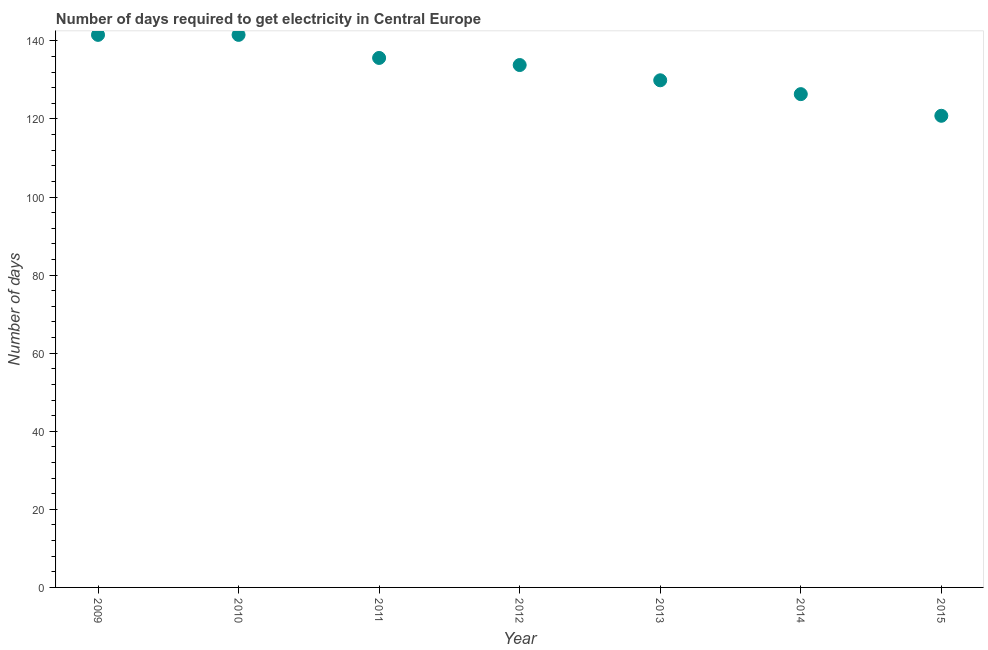What is the time to get electricity in 2010?
Your answer should be compact. 141.55. Across all years, what is the maximum time to get electricity?
Offer a terse response. 141.55. Across all years, what is the minimum time to get electricity?
Make the answer very short. 120.82. In which year was the time to get electricity minimum?
Your response must be concise. 2015. What is the sum of the time to get electricity?
Provide a short and direct response. 929.64. What is the average time to get electricity per year?
Make the answer very short. 132.81. What is the median time to get electricity?
Offer a terse response. 133.82. In how many years, is the time to get electricity greater than 72 ?
Your answer should be very brief. 7. What is the ratio of the time to get electricity in 2011 to that in 2014?
Make the answer very short. 1.07. Is the time to get electricity in 2013 less than that in 2014?
Your response must be concise. No. Is the difference between the time to get electricity in 2011 and 2012 greater than the difference between any two years?
Keep it short and to the point. No. What is the difference between the highest and the second highest time to get electricity?
Your answer should be very brief. 0. Is the sum of the time to get electricity in 2009 and 2013 greater than the maximum time to get electricity across all years?
Make the answer very short. Yes. What is the difference between the highest and the lowest time to get electricity?
Offer a terse response. 20.73. In how many years, is the time to get electricity greater than the average time to get electricity taken over all years?
Your answer should be compact. 4. Does the time to get electricity monotonically increase over the years?
Your response must be concise. No. How many dotlines are there?
Ensure brevity in your answer.  1. How many years are there in the graph?
Your answer should be compact. 7. Are the values on the major ticks of Y-axis written in scientific E-notation?
Your answer should be compact. No. Does the graph contain grids?
Keep it short and to the point. No. What is the title of the graph?
Provide a short and direct response. Number of days required to get electricity in Central Europe. What is the label or title of the Y-axis?
Your answer should be compact. Number of days. What is the Number of days in 2009?
Offer a terse response. 141.55. What is the Number of days in 2010?
Provide a short and direct response. 141.55. What is the Number of days in 2011?
Your response must be concise. 135.64. What is the Number of days in 2012?
Ensure brevity in your answer.  133.82. What is the Number of days in 2013?
Give a very brief answer. 129.91. What is the Number of days in 2014?
Your answer should be very brief. 126.36. What is the Number of days in 2015?
Provide a short and direct response. 120.82. What is the difference between the Number of days in 2009 and 2010?
Provide a short and direct response. 0. What is the difference between the Number of days in 2009 and 2011?
Keep it short and to the point. 5.91. What is the difference between the Number of days in 2009 and 2012?
Keep it short and to the point. 7.73. What is the difference between the Number of days in 2009 and 2013?
Your response must be concise. 11.64. What is the difference between the Number of days in 2009 and 2014?
Your answer should be compact. 15.18. What is the difference between the Number of days in 2009 and 2015?
Keep it short and to the point. 20.73. What is the difference between the Number of days in 2010 and 2011?
Keep it short and to the point. 5.91. What is the difference between the Number of days in 2010 and 2012?
Offer a very short reply. 7.73. What is the difference between the Number of days in 2010 and 2013?
Your answer should be compact. 11.64. What is the difference between the Number of days in 2010 and 2014?
Keep it short and to the point. 15.18. What is the difference between the Number of days in 2010 and 2015?
Provide a short and direct response. 20.73. What is the difference between the Number of days in 2011 and 2012?
Make the answer very short. 1.82. What is the difference between the Number of days in 2011 and 2013?
Offer a terse response. 5.73. What is the difference between the Number of days in 2011 and 2014?
Offer a very short reply. 9.27. What is the difference between the Number of days in 2011 and 2015?
Provide a short and direct response. 14.82. What is the difference between the Number of days in 2012 and 2013?
Give a very brief answer. 3.91. What is the difference between the Number of days in 2012 and 2014?
Provide a short and direct response. 7.45. What is the difference between the Number of days in 2013 and 2014?
Make the answer very short. 3.55. What is the difference between the Number of days in 2013 and 2015?
Provide a succinct answer. 9.09. What is the difference between the Number of days in 2014 and 2015?
Your answer should be very brief. 5.55. What is the ratio of the Number of days in 2009 to that in 2011?
Give a very brief answer. 1.04. What is the ratio of the Number of days in 2009 to that in 2012?
Make the answer very short. 1.06. What is the ratio of the Number of days in 2009 to that in 2013?
Offer a very short reply. 1.09. What is the ratio of the Number of days in 2009 to that in 2014?
Your answer should be compact. 1.12. What is the ratio of the Number of days in 2009 to that in 2015?
Provide a short and direct response. 1.17. What is the ratio of the Number of days in 2010 to that in 2011?
Your response must be concise. 1.04. What is the ratio of the Number of days in 2010 to that in 2012?
Provide a succinct answer. 1.06. What is the ratio of the Number of days in 2010 to that in 2013?
Give a very brief answer. 1.09. What is the ratio of the Number of days in 2010 to that in 2014?
Make the answer very short. 1.12. What is the ratio of the Number of days in 2010 to that in 2015?
Make the answer very short. 1.17. What is the ratio of the Number of days in 2011 to that in 2012?
Your response must be concise. 1.01. What is the ratio of the Number of days in 2011 to that in 2013?
Provide a short and direct response. 1.04. What is the ratio of the Number of days in 2011 to that in 2014?
Your answer should be very brief. 1.07. What is the ratio of the Number of days in 2011 to that in 2015?
Provide a succinct answer. 1.12. What is the ratio of the Number of days in 2012 to that in 2014?
Provide a succinct answer. 1.06. What is the ratio of the Number of days in 2012 to that in 2015?
Give a very brief answer. 1.11. What is the ratio of the Number of days in 2013 to that in 2014?
Your answer should be compact. 1.03. What is the ratio of the Number of days in 2013 to that in 2015?
Make the answer very short. 1.07. What is the ratio of the Number of days in 2014 to that in 2015?
Make the answer very short. 1.05. 